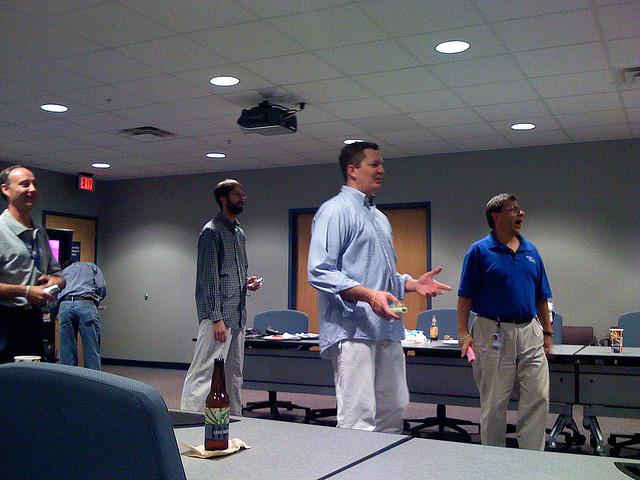What is the purpose of the black object on the ceiling?

Choices:
A) projecting
B) light
C) heating
D) cooling projecting 